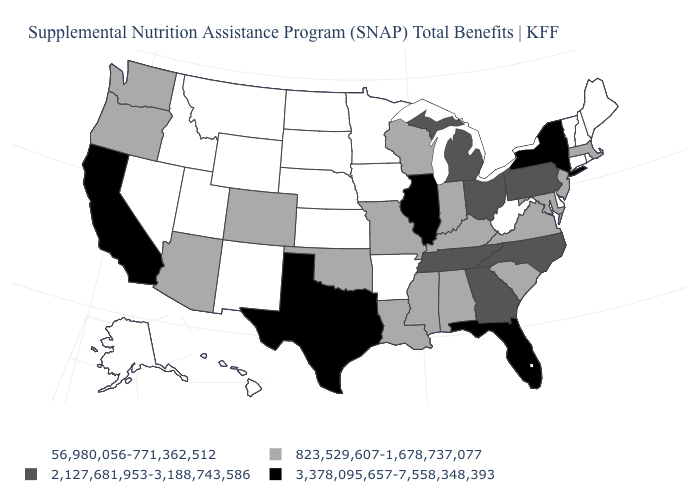Among the states that border Indiana , which have the lowest value?
Give a very brief answer. Kentucky. Which states have the lowest value in the USA?
Concise answer only. Alaska, Arkansas, Connecticut, Delaware, Hawaii, Idaho, Iowa, Kansas, Maine, Minnesota, Montana, Nebraska, Nevada, New Hampshire, New Mexico, North Dakota, Rhode Island, South Dakota, Utah, Vermont, West Virginia, Wyoming. What is the value of West Virginia?
Answer briefly. 56,980,056-771,362,512. What is the value of Idaho?
Give a very brief answer. 56,980,056-771,362,512. Does Virginia have the same value as Washington?
Keep it brief. Yes. Which states have the lowest value in the MidWest?
Keep it brief. Iowa, Kansas, Minnesota, Nebraska, North Dakota, South Dakota. Does the first symbol in the legend represent the smallest category?
Give a very brief answer. Yes. Name the states that have a value in the range 2,127,681,953-3,188,743,586?
Answer briefly. Georgia, Michigan, North Carolina, Ohio, Pennsylvania, Tennessee. Which states have the highest value in the USA?
Keep it brief. California, Florida, Illinois, New York, Texas. Which states have the highest value in the USA?
Keep it brief. California, Florida, Illinois, New York, Texas. Does Arkansas have the highest value in the USA?
Keep it brief. No. What is the lowest value in states that border Delaware?
Short answer required. 823,529,607-1,678,737,077. Which states have the lowest value in the USA?
Write a very short answer. Alaska, Arkansas, Connecticut, Delaware, Hawaii, Idaho, Iowa, Kansas, Maine, Minnesota, Montana, Nebraska, Nevada, New Hampshire, New Mexico, North Dakota, Rhode Island, South Dakota, Utah, Vermont, West Virginia, Wyoming. Does the map have missing data?
Write a very short answer. No. Among the states that border Colorado , does Oklahoma have the lowest value?
Short answer required. No. 